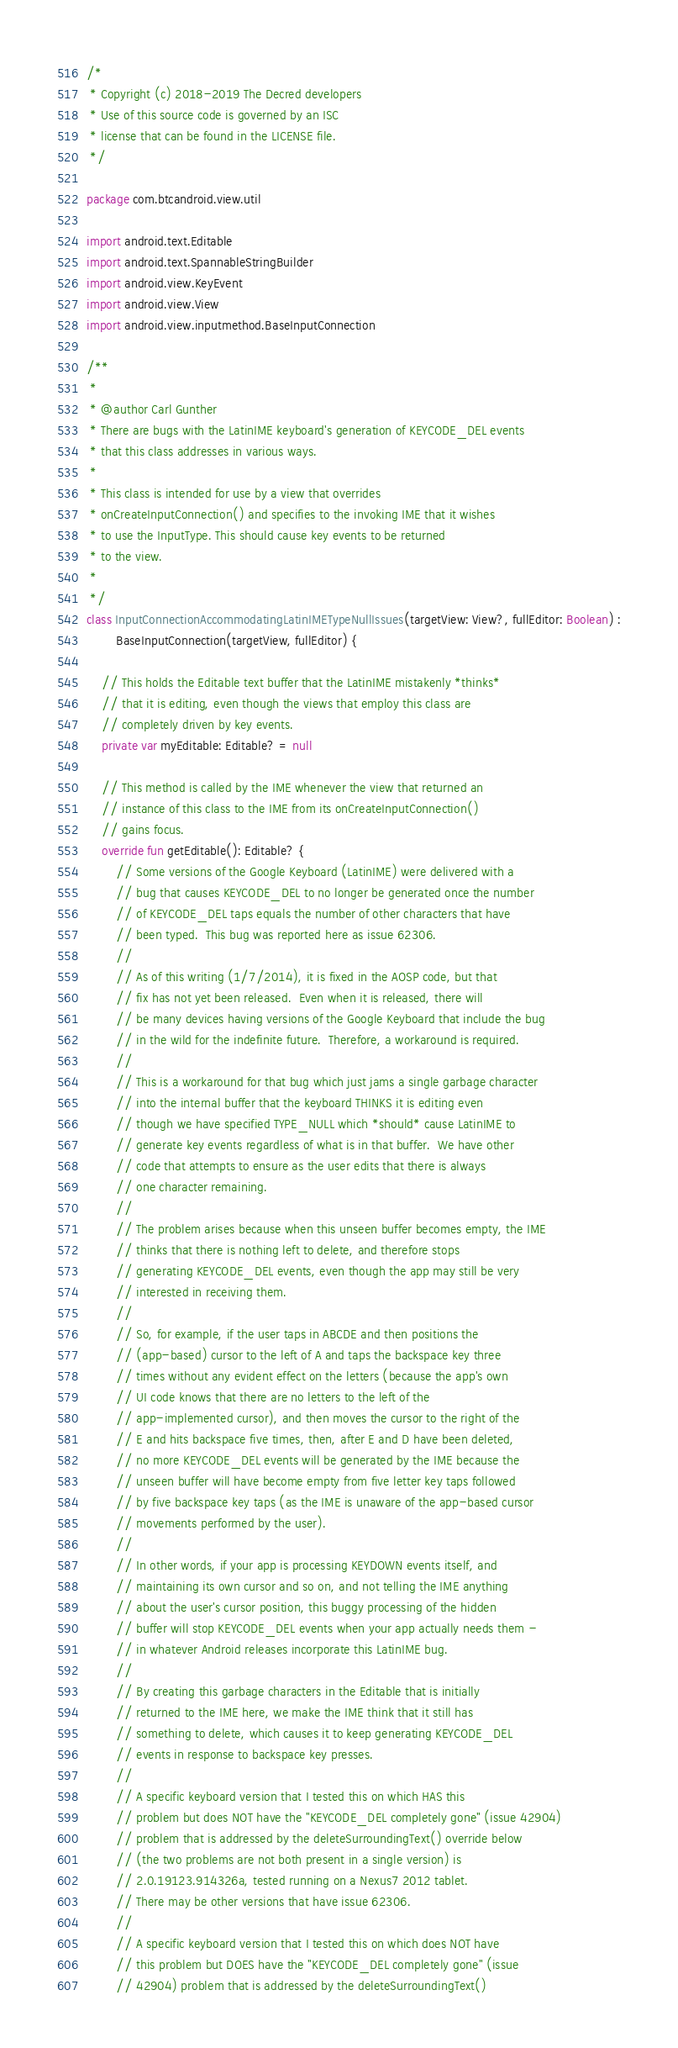<code> <loc_0><loc_0><loc_500><loc_500><_Kotlin_>/*
 * Copyright (c) 2018-2019 The Decred developers
 * Use of this source code is governed by an ISC
 * license that can be found in the LICENSE file.
 */

package com.btcandroid.view.util

import android.text.Editable
import android.text.SpannableStringBuilder
import android.view.KeyEvent
import android.view.View
import android.view.inputmethod.BaseInputConnection

/**
 *
 * @author Carl Gunther
 * There are bugs with the LatinIME keyboard's generation of KEYCODE_DEL events
 * that this class addresses in various ways.
 *
 * This class is intended for use by a view that overrides
 * onCreateInputConnection() and specifies to the invoking IME that it wishes
 * to use the InputType. This should cause key events to be returned
 * to the view.
 *
 */
class InputConnectionAccommodatingLatinIMETypeNullIssues(targetView: View?, fullEditor: Boolean) :
        BaseInputConnection(targetView, fullEditor) {

    // This holds the Editable text buffer that the LatinIME mistakenly *thinks*
    // that it is editing, even though the views that employ this class are
    // completely driven by key events.
    private var myEditable: Editable? = null

    // This method is called by the IME whenever the view that returned an
    // instance of this class to the IME from its onCreateInputConnection()
    // gains focus.
    override fun getEditable(): Editable? {
        // Some versions of the Google Keyboard (LatinIME) were delivered with a
        // bug that causes KEYCODE_DEL to no longer be generated once the number
        // of KEYCODE_DEL taps equals the number of other characters that have
        // been typed.  This bug was reported here as issue 62306.
        //
        // As of this writing (1/7/2014), it is fixed in the AOSP code, but that
        // fix has not yet been released.  Even when it is released, there will
        // be many devices having versions of the Google Keyboard that include the bug
        // in the wild for the indefinite future.  Therefore, a workaround is required.
        //
        // This is a workaround for that bug which just jams a single garbage character
        // into the internal buffer that the keyboard THINKS it is editing even
        // though we have specified TYPE_NULL which *should* cause LatinIME to
        // generate key events regardless of what is in that buffer.  We have other
        // code that attempts to ensure as the user edits that there is always
        // one character remaining.
        //
        // The problem arises because when this unseen buffer becomes empty, the IME
        // thinks that there is nothing left to delete, and therefore stops
        // generating KEYCODE_DEL events, even though the app may still be very
        // interested in receiving them.
        //
        // So, for example, if the user taps in ABCDE and then positions the
        // (app-based) cursor to the left of A and taps the backspace key three
        // times without any evident effect on the letters (because the app's own
        // UI code knows that there are no letters to the left of the
        // app-implemented cursor), and then moves the cursor to the right of the
        // E and hits backspace five times, then, after E and D have been deleted,
        // no more KEYCODE_DEL events will be generated by the IME because the
        // unseen buffer will have become empty from five letter key taps followed
        // by five backspace key taps (as the IME is unaware of the app-based cursor
        // movements performed by the user).
        //
        // In other words, if your app is processing KEYDOWN events itself, and
        // maintaining its own cursor and so on, and not telling the IME anything
        // about the user's cursor position, this buggy processing of the hidden
        // buffer will stop KEYCODE_DEL events when your app actually needs them -
        // in whatever Android releases incorporate this LatinIME bug.
        //
        // By creating this garbage characters in the Editable that is initially
        // returned to the IME here, we make the IME think that it still has
        // something to delete, which causes it to keep generating KEYCODE_DEL
        // events in response to backspace key presses.
        //
        // A specific keyboard version that I tested this on which HAS this
        // problem but does NOT have the "KEYCODE_DEL completely gone" (issue 42904)
        // problem that is addressed by the deleteSurroundingText() override below
        // (the two problems are not both present in a single version) is
        // 2.0.19123.914326a, tested running on a Nexus7 2012 tablet.
        // There may be other versions that have issue 62306.
        //
        // A specific keyboard version that I tested this on which does NOT have
        // this problem but DOES have the "KEYCODE_DEL completely gone" (issue
        // 42904) problem that is addressed by the deleteSurroundingText()</code> 